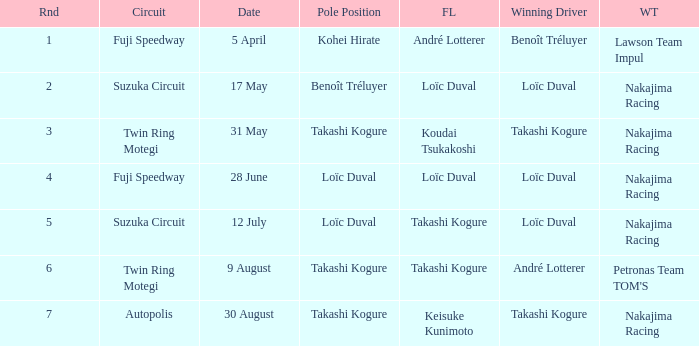Could you help me parse every detail presented in this table? {'header': ['Rnd', 'Circuit', 'Date', 'Pole Position', 'FL', 'Winning Driver', 'WT'], 'rows': [['1', 'Fuji Speedway', '5 April', 'Kohei Hirate', 'André Lotterer', 'Benoît Tréluyer', 'Lawson Team Impul'], ['2', 'Suzuka Circuit', '17 May', 'Benoît Tréluyer', 'Loïc Duval', 'Loïc Duval', 'Nakajima Racing'], ['3', 'Twin Ring Motegi', '31 May', 'Takashi Kogure', 'Koudai Tsukakoshi', 'Takashi Kogure', 'Nakajima Racing'], ['4', 'Fuji Speedway', '28 June', 'Loïc Duval', 'Loïc Duval', 'Loïc Duval', 'Nakajima Racing'], ['5', 'Suzuka Circuit', '12 July', 'Loïc Duval', 'Takashi Kogure', 'Loïc Duval', 'Nakajima Racing'], ['6', 'Twin Ring Motegi', '9 August', 'Takashi Kogure', 'Takashi Kogure', 'André Lotterer', "Petronas Team TOM'S"], ['7', 'Autopolis', '30 August', 'Takashi Kogure', 'Keisuke Kunimoto', 'Takashi Kogure', 'Nakajima Racing']]} Who was the driver for the winning team Lawson Team Impul? Benoît Tréluyer. 